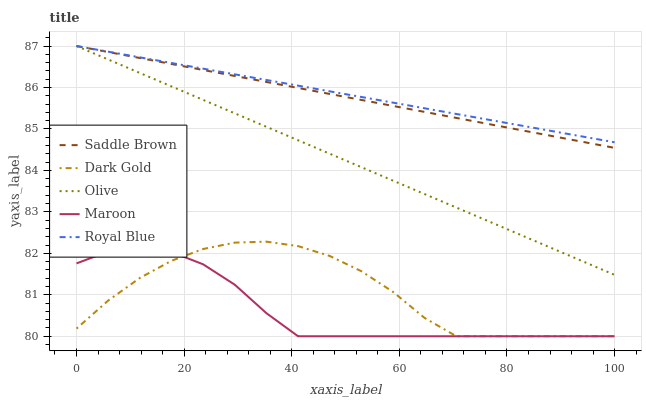Does Maroon have the minimum area under the curve?
Answer yes or no. Yes. Does Royal Blue have the maximum area under the curve?
Answer yes or no. Yes. Does Saddle Brown have the minimum area under the curve?
Answer yes or no. No. Does Saddle Brown have the maximum area under the curve?
Answer yes or no. No. Is Royal Blue the smoothest?
Answer yes or no. Yes. Is Dark Gold the roughest?
Answer yes or no. Yes. Is Saddle Brown the smoothest?
Answer yes or no. No. Is Saddle Brown the roughest?
Answer yes or no. No. Does Maroon have the lowest value?
Answer yes or no. Yes. Does Saddle Brown have the lowest value?
Answer yes or no. No. Does Saddle Brown have the highest value?
Answer yes or no. Yes. Does Maroon have the highest value?
Answer yes or no. No. Is Dark Gold less than Olive?
Answer yes or no. Yes. Is Saddle Brown greater than Maroon?
Answer yes or no. Yes. Does Royal Blue intersect Saddle Brown?
Answer yes or no. Yes. Is Royal Blue less than Saddle Brown?
Answer yes or no. No. Is Royal Blue greater than Saddle Brown?
Answer yes or no. No. Does Dark Gold intersect Olive?
Answer yes or no. No. 